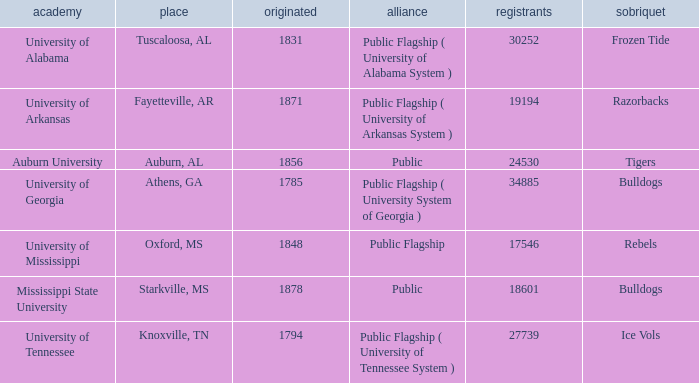What is the maximum enrollment of the schools? 34885.0. 